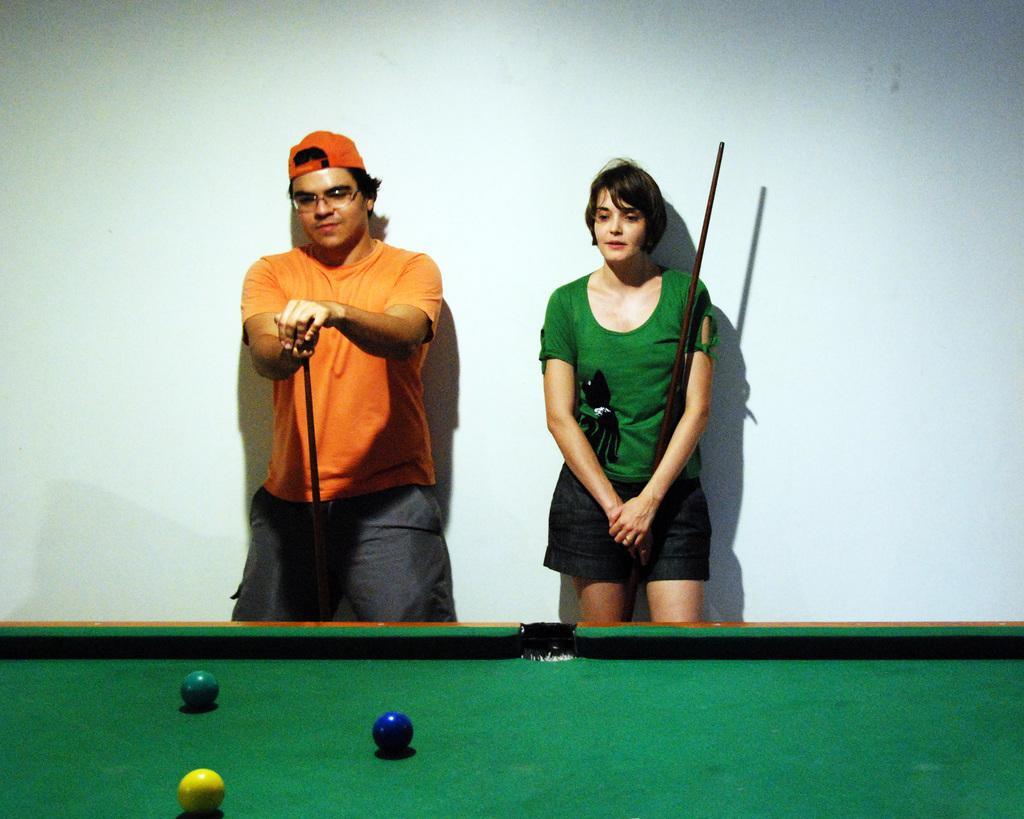Can you describe this image briefly? Inn this picture there are two person one man one woman standing near the wall. They are holding sticks. The man is wearing orange t shirt and orange cap. The woman is wearing green t shirt. in front of them there is a snooker table. On the table there are three balls> The wall is white in color. 